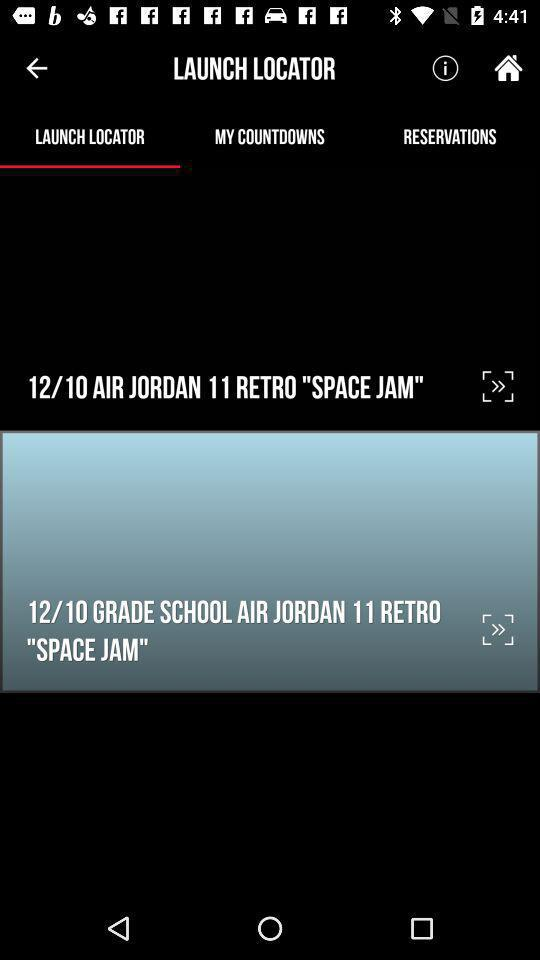What is the email address? The email address is appcrawler6@gmail.com. 